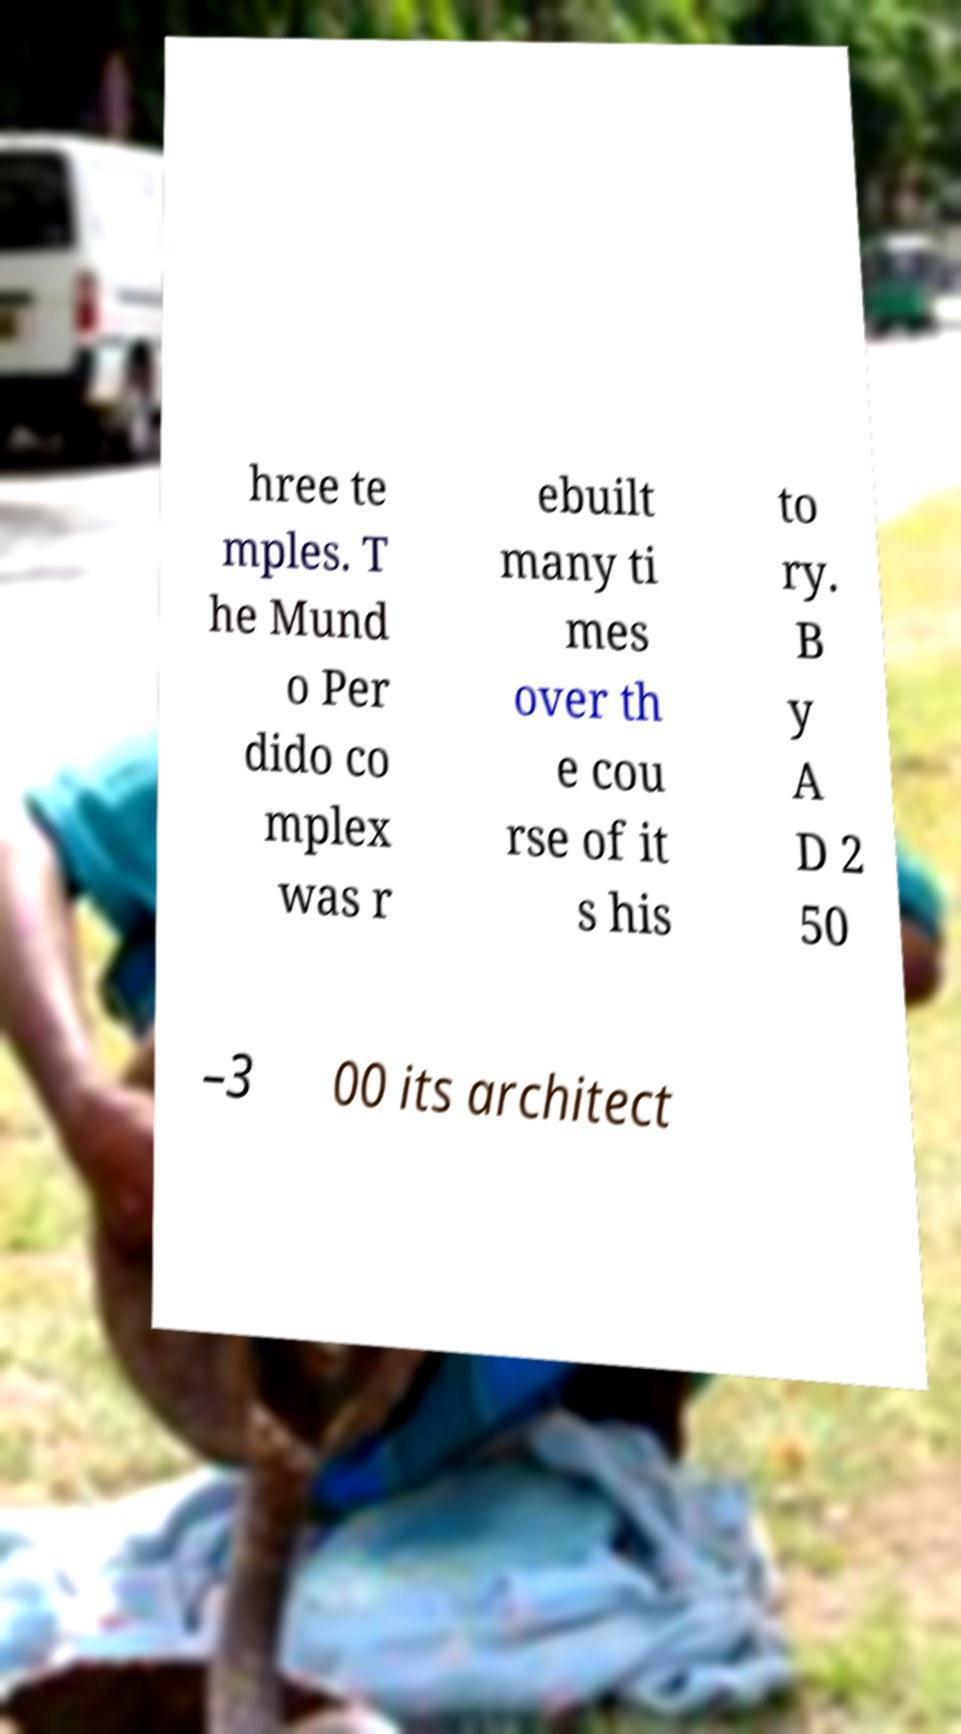Please identify and transcribe the text found in this image. hree te mples. T he Mund o Per dido co mplex was r ebuilt many ti mes over th e cou rse of it s his to ry. B y A D 2 50 –3 00 its architect 